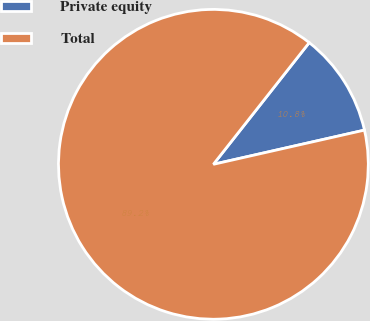<chart> <loc_0><loc_0><loc_500><loc_500><pie_chart><fcel>Private equity<fcel>Total<nl><fcel>10.84%<fcel>89.16%<nl></chart> 